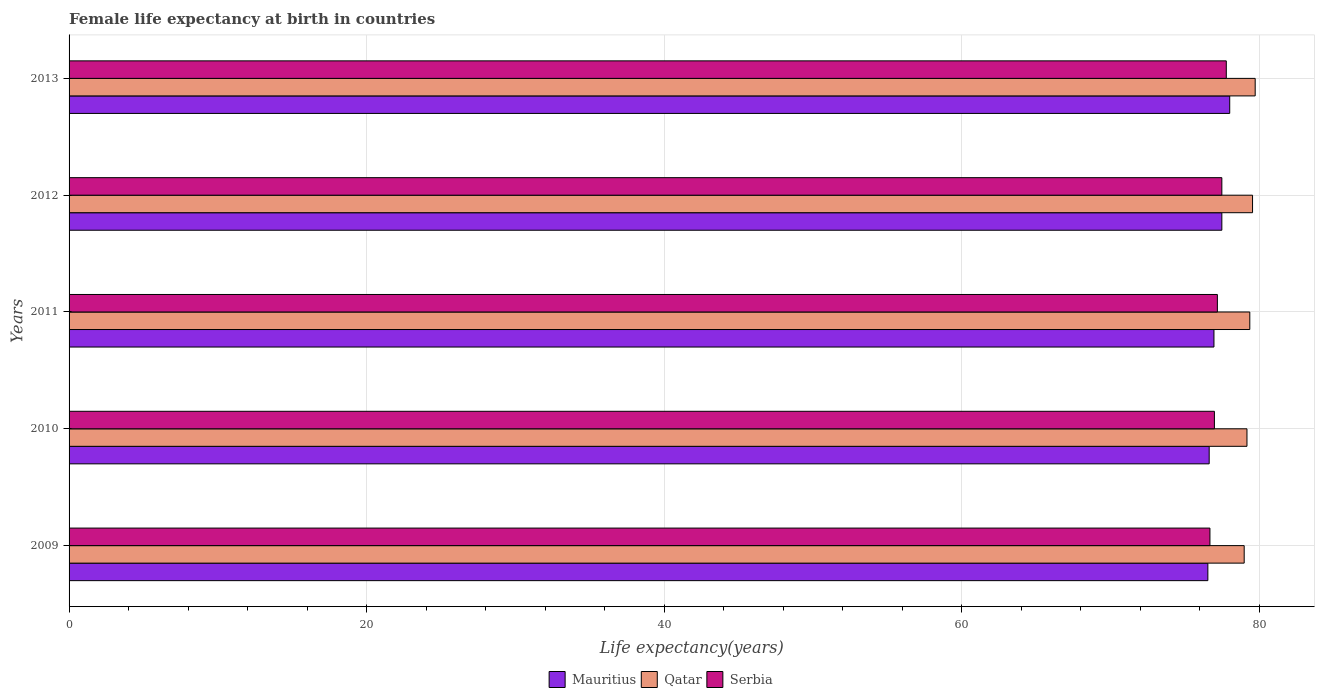How many different coloured bars are there?
Offer a terse response. 3. How many groups of bars are there?
Provide a short and direct response. 5. Are the number of bars on each tick of the Y-axis equal?
Provide a succinct answer. Yes. What is the label of the 5th group of bars from the top?
Offer a very short reply. 2009. In how many cases, is the number of bars for a given year not equal to the number of legend labels?
Make the answer very short. 0. What is the female life expectancy at birth in Mauritius in 2009?
Your answer should be very brief. 76.56. Across all years, what is the maximum female life expectancy at birth in Qatar?
Your answer should be very brief. 79.74. Across all years, what is the minimum female life expectancy at birth in Serbia?
Provide a succinct answer. 76.7. What is the total female life expectancy at birth in Qatar in the graph?
Offer a very short reply. 396.88. What is the difference between the female life expectancy at birth in Qatar in 2009 and that in 2010?
Provide a short and direct response. -0.19. What is the difference between the female life expectancy at birth in Qatar in 2011 and the female life expectancy at birth in Serbia in 2012?
Your answer should be very brief. 1.88. What is the average female life expectancy at birth in Mauritius per year?
Your response must be concise. 77.14. In the year 2013, what is the difference between the female life expectancy at birth in Mauritius and female life expectancy at birth in Qatar?
Make the answer very short. -1.71. In how many years, is the female life expectancy at birth in Serbia greater than 44 years?
Make the answer very short. 5. What is the ratio of the female life expectancy at birth in Serbia in 2009 to that in 2011?
Provide a short and direct response. 0.99. Is the female life expectancy at birth in Mauritius in 2012 less than that in 2013?
Provide a succinct answer. Yes. Is the difference between the female life expectancy at birth in Mauritius in 2009 and 2011 greater than the difference between the female life expectancy at birth in Qatar in 2009 and 2011?
Offer a terse response. No. What is the difference between the highest and the second highest female life expectancy at birth in Serbia?
Ensure brevity in your answer.  0.3. What is the difference between the highest and the lowest female life expectancy at birth in Mauritius?
Keep it short and to the point. 1.47. What does the 3rd bar from the top in 2012 represents?
Your response must be concise. Mauritius. What does the 2nd bar from the bottom in 2010 represents?
Your response must be concise. Qatar. How many bars are there?
Ensure brevity in your answer.  15. How many years are there in the graph?
Keep it short and to the point. 5. Are the values on the major ticks of X-axis written in scientific E-notation?
Your answer should be very brief. No. Does the graph contain any zero values?
Give a very brief answer. No. How many legend labels are there?
Offer a very short reply. 3. What is the title of the graph?
Offer a very short reply. Female life expectancy at birth in countries. Does "Venezuela" appear as one of the legend labels in the graph?
Your answer should be compact. No. What is the label or title of the X-axis?
Your answer should be very brief. Life expectancy(years). What is the Life expectancy(years) in Mauritius in 2009?
Keep it short and to the point. 76.56. What is the Life expectancy(years) of Qatar in 2009?
Ensure brevity in your answer.  79. What is the Life expectancy(years) of Serbia in 2009?
Ensure brevity in your answer.  76.7. What is the Life expectancy(years) in Mauritius in 2010?
Provide a succinct answer. 76.65. What is the Life expectancy(years) in Qatar in 2010?
Offer a very short reply. 79.19. What is the Life expectancy(years) in Mauritius in 2011?
Your answer should be very brief. 76.97. What is the Life expectancy(years) in Qatar in 2011?
Keep it short and to the point. 79.38. What is the Life expectancy(years) of Serbia in 2011?
Provide a succinct answer. 77.2. What is the Life expectancy(years) of Mauritius in 2012?
Your answer should be very brief. 77.5. What is the Life expectancy(years) of Qatar in 2012?
Offer a very short reply. 79.56. What is the Life expectancy(years) in Serbia in 2012?
Offer a terse response. 77.5. What is the Life expectancy(years) of Mauritius in 2013?
Provide a short and direct response. 78.03. What is the Life expectancy(years) in Qatar in 2013?
Your answer should be very brief. 79.74. What is the Life expectancy(years) of Serbia in 2013?
Provide a succinct answer. 77.8. Across all years, what is the maximum Life expectancy(years) of Mauritius?
Provide a short and direct response. 78.03. Across all years, what is the maximum Life expectancy(years) in Qatar?
Ensure brevity in your answer.  79.74. Across all years, what is the maximum Life expectancy(years) of Serbia?
Make the answer very short. 77.8. Across all years, what is the minimum Life expectancy(years) of Mauritius?
Your response must be concise. 76.56. Across all years, what is the minimum Life expectancy(years) in Qatar?
Ensure brevity in your answer.  79. Across all years, what is the minimum Life expectancy(years) in Serbia?
Provide a short and direct response. 76.7. What is the total Life expectancy(years) in Mauritius in the graph?
Your response must be concise. 385.71. What is the total Life expectancy(years) of Qatar in the graph?
Your answer should be very brief. 396.88. What is the total Life expectancy(years) in Serbia in the graph?
Provide a succinct answer. 386.2. What is the difference between the Life expectancy(years) of Mauritius in 2009 and that in 2010?
Provide a short and direct response. -0.09. What is the difference between the Life expectancy(years) in Qatar in 2009 and that in 2010?
Your response must be concise. -0.19. What is the difference between the Life expectancy(years) in Serbia in 2009 and that in 2010?
Provide a short and direct response. -0.3. What is the difference between the Life expectancy(years) in Mauritius in 2009 and that in 2011?
Ensure brevity in your answer.  -0.41. What is the difference between the Life expectancy(years) of Qatar in 2009 and that in 2011?
Your answer should be compact. -0.38. What is the difference between the Life expectancy(years) in Mauritius in 2009 and that in 2012?
Your answer should be very brief. -0.94. What is the difference between the Life expectancy(years) in Qatar in 2009 and that in 2012?
Offer a very short reply. -0.56. What is the difference between the Life expectancy(years) in Serbia in 2009 and that in 2012?
Offer a very short reply. -0.8. What is the difference between the Life expectancy(years) of Mauritius in 2009 and that in 2013?
Ensure brevity in your answer.  -1.47. What is the difference between the Life expectancy(years) of Qatar in 2009 and that in 2013?
Keep it short and to the point. -0.74. What is the difference between the Life expectancy(years) in Mauritius in 2010 and that in 2011?
Offer a very short reply. -0.32. What is the difference between the Life expectancy(years) in Qatar in 2010 and that in 2011?
Offer a terse response. -0.19. What is the difference between the Life expectancy(years) in Serbia in 2010 and that in 2011?
Provide a short and direct response. -0.2. What is the difference between the Life expectancy(years) of Mauritius in 2010 and that in 2012?
Your answer should be very brief. -0.85. What is the difference between the Life expectancy(years) in Qatar in 2010 and that in 2012?
Your answer should be very brief. -0.38. What is the difference between the Life expectancy(years) of Mauritius in 2010 and that in 2013?
Provide a succinct answer. -1.38. What is the difference between the Life expectancy(years) in Qatar in 2010 and that in 2013?
Offer a terse response. -0.55. What is the difference between the Life expectancy(years) of Serbia in 2010 and that in 2013?
Provide a short and direct response. -0.8. What is the difference between the Life expectancy(years) in Mauritius in 2011 and that in 2012?
Ensure brevity in your answer.  -0.53. What is the difference between the Life expectancy(years) of Qatar in 2011 and that in 2012?
Give a very brief answer. -0.18. What is the difference between the Life expectancy(years) in Serbia in 2011 and that in 2012?
Ensure brevity in your answer.  -0.3. What is the difference between the Life expectancy(years) in Mauritius in 2011 and that in 2013?
Provide a short and direct response. -1.06. What is the difference between the Life expectancy(years) in Qatar in 2011 and that in 2013?
Provide a short and direct response. -0.36. What is the difference between the Life expectancy(years) in Mauritius in 2012 and that in 2013?
Make the answer very short. -0.53. What is the difference between the Life expectancy(years) of Qatar in 2012 and that in 2013?
Make the answer very short. -0.18. What is the difference between the Life expectancy(years) in Serbia in 2012 and that in 2013?
Offer a terse response. -0.3. What is the difference between the Life expectancy(years) in Mauritius in 2009 and the Life expectancy(years) in Qatar in 2010?
Ensure brevity in your answer.  -2.63. What is the difference between the Life expectancy(years) of Mauritius in 2009 and the Life expectancy(years) of Serbia in 2010?
Your answer should be compact. -0.44. What is the difference between the Life expectancy(years) in Qatar in 2009 and the Life expectancy(years) in Serbia in 2010?
Provide a short and direct response. 2. What is the difference between the Life expectancy(years) of Mauritius in 2009 and the Life expectancy(years) of Qatar in 2011?
Ensure brevity in your answer.  -2.82. What is the difference between the Life expectancy(years) of Mauritius in 2009 and the Life expectancy(years) of Serbia in 2011?
Your answer should be compact. -0.64. What is the difference between the Life expectancy(years) in Qatar in 2009 and the Life expectancy(years) in Serbia in 2011?
Offer a terse response. 1.8. What is the difference between the Life expectancy(years) in Mauritius in 2009 and the Life expectancy(years) in Qatar in 2012?
Your answer should be compact. -3. What is the difference between the Life expectancy(years) in Mauritius in 2009 and the Life expectancy(years) in Serbia in 2012?
Your answer should be compact. -0.94. What is the difference between the Life expectancy(years) in Qatar in 2009 and the Life expectancy(years) in Serbia in 2012?
Provide a short and direct response. 1.5. What is the difference between the Life expectancy(years) of Mauritius in 2009 and the Life expectancy(years) of Qatar in 2013?
Provide a succinct answer. -3.18. What is the difference between the Life expectancy(years) of Mauritius in 2009 and the Life expectancy(years) of Serbia in 2013?
Offer a very short reply. -1.24. What is the difference between the Life expectancy(years) in Qatar in 2009 and the Life expectancy(years) in Serbia in 2013?
Your answer should be very brief. 1.2. What is the difference between the Life expectancy(years) in Mauritius in 2010 and the Life expectancy(years) in Qatar in 2011?
Your answer should be very brief. -2.73. What is the difference between the Life expectancy(years) in Mauritius in 2010 and the Life expectancy(years) in Serbia in 2011?
Provide a succinct answer. -0.55. What is the difference between the Life expectancy(years) of Qatar in 2010 and the Life expectancy(years) of Serbia in 2011?
Your answer should be very brief. 1.99. What is the difference between the Life expectancy(years) of Mauritius in 2010 and the Life expectancy(years) of Qatar in 2012?
Ensure brevity in your answer.  -2.92. What is the difference between the Life expectancy(years) in Mauritius in 2010 and the Life expectancy(years) in Serbia in 2012?
Offer a terse response. -0.85. What is the difference between the Life expectancy(years) of Qatar in 2010 and the Life expectancy(years) of Serbia in 2012?
Offer a terse response. 1.69. What is the difference between the Life expectancy(years) of Mauritius in 2010 and the Life expectancy(years) of Qatar in 2013?
Your answer should be very brief. -3.09. What is the difference between the Life expectancy(years) of Mauritius in 2010 and the Life expectancy(years) of Serbia in 2013?
Provide a short and direct response. -1.15. What is the difference between the Life expectancy(years) of Qatar in 2010 and the Life expectancy(years) of Serbia in 2013?
Keep it short and to the point. 1.39. What is the difference between the Life expectancy(years) in Mauritius in 2011 and the Life expectancy(years) in Qatar in 2012?
Offer a very short reply. -2.6. What is the difference between the Life expectancy(years) in Mauritius in 2011 and the Life expectancy(years) in Serbia in 2012?
Keep it short and to the point. -0.53. What is the difference between the Life expectancy(years) in Qatar in 2011 and the Life expectancy(years) in Serbia in 2012?
Give a very brief answer. 1.88. What is the difference between the Life expectancy(years) of Mauritius in 2011 and the Life expectancy(years) of Qatar in 2013?
Give a very brief answer. -2.77. What is the difference between the Life expectancy(years) in Mauritius in 2011 and the Life expectancy(years) in Serbia in 2013?
Your answer should be compact. -0.83. What is the difference between the Life expectancy(years) in Qatar in 2011 and the Life expectancy(years) in Serbia in 2013?
Your answer should be compact. 1.58. What is the difference between the Life expectancy(years) of Mauritius in 2012 and the Life expectancy(years) of Qatar in 2013?
Offer a very short reply. -2.24. What is the difference between the Life expectancy(years) in Mauritius in 2012 and the Life expectancy(years) in Serbia in 2013?
Your answer should be very brief. -0.3. What is the difference between the Life expectancy(years) in Qatar in 2012 and the Life expectancy(years) in Serbia in 2013?
Keep it short and to the point. 1.76. What is the average Life expectancy(years) of Mauritius per year?
Give a very brief answer. 77.14. What is the average Life expectancy(years) in Qatar per year?
Your answer should be very brief. 79.38. What is the average Life expectancy(years) of Serbia per year?
Provide a short and direct response. 77.24. In the year 2009, what is the difference between the Life expectancy(years) of Mauritius and Life expectancy(years) of Qatar?
Give a very brief answer. -2.44. In the year 2009, what is the difference between the Life expectancy(years) of Mauritius and Life expectancy(years) of Serbia?
Offer a very short reply. -0.14. In the year 2009, what is the difference between the Life expectancy(years) of Qatar and Life expectancy(years) of Serbia?
Your answer should be compact. 2.3. In the year 2010, what is the difference between the Life expectancy(years) in Mauritius and Life expectancy(years) in Qatar?
Ensure brevity in your answer.  -2.54. In the year 2010, what is the difference between the Life expectancy(years) in Mauritius and Life expectancy(years) in Serbia?
Offer a terse response. -0.35. In the year 2010, what is the difference between the Life expectancy(years) in Qatar and Life expectancy(years) in Serbia?
Provide a short and direct response. 2.19. In the year 2011, what is the difference between the Life expectancy(years) of Mauritius and Life expectancy(years) of Qatar?
Offer a very short reply. -2.41. In the year 2011, what is the difference between the Life expectancy(years) in Mauritius and Life expectancy(years) in Serbia?
Your response must be concise. -0.23. In the year 2011, what is the difference between the Life expectancy(years) of Qatar and Life expectancy(years) of Serbia?
Keep it short and to the point. 2.18. In the year 2012, what is the difference between the Life expectancy(years) in Mauritius and Life expectancy(years) in Qatar?
Provide a succinct answer. -2.06. In the year 2012, what is the difference between the Life expectancy(years) of Mauritius and Life expectancy(years) of Serbia?
Provide a short and direct response. 0. In the year 2012, what is the difference between the Life expectancy(years) in Qatar and Life expectancy(years) in Serbia?
Offer a very short reply. 2.06. In the year 2013, what is the difference between the Life expectancy(years) in Mauritius and Life expectancy(years) in Qatar?
Keep it short and to the point. -1.71. In the year 2013, what is the difference between the Life expectancy(years) of Mauritius and Life expectancy(years) of Serbia?
Provide a succinct answer. 0.23. In the year 2013, what is the difference between the Life expectancy(years) in Qatar and Life expectancy(years) in Serbia?
Provide a succinct answer. 1.94. What is the ratio of the Life expectancy(years) in Qatar in 2009 to that in 2010?
Give a very brief answer. 1. What is the ratio of the Life expectancy(years) in Mauritius in 2009 to that in 2011?
Offer a terse response. 0.99. What is the ratio of the Life expectancy(years) in Qatar in 2009 to that in 2011?
Provide a succinct answer. 1. What is the ratio of the Life expectancy(years) in Mauritius in 2009 to that in 2012?
Give a very brief answer. 0.99. What is the ratio of the Life expectancy(years) in Qatar in 2009 to that in 2012?
Provide a short and direct response. 0.99. What is the ratio of the Life expectancy(years) in Serbia in 2009 to that in 2012?
Provide a succinct answer. 0.99. What is the ratio of the Life expectancy(years) in Mauritius in 2009 to that in 2013?
Provide a succinct answer. 0.98. What is the ratio of the Life expectancy(years) in Serbia in 2009 to that in 2013?
Give a very brief answer. 0.99. What is the ratio of the Life expectancy(years) in Mauritius in 2010 to that in 2011?
Your answer should be compact. 1. What is the ratio of the Life expectancy(years) in Serbia in 2010 to that in 2012?
Provide a short and direct response. 0.99. What is the ratio of the Life expectancy(years) in Mauritius in 2010 to that in 2013?
Your answer should be compact. 0.98. What is the ratio of the Life expectancy(years) in Qatar in 2010 to that in 2013?
Make the answer very short. 0.99. What is the ratio of the Life expectancy(years) in Serbia in 2011 to that in 2012?
Your answer should be compact. 1. What is the ratio of the Life expectancy(years) of Mauritius in 2011 to that in 2013?
Your answer should be very brief. 0.99. What is the ratio of the Life expectancy(years) of Qatar in 2012 to that in 2013?
Provide a short and direct response. 1. What is the difference between the highest and the second highest Life expectancy(years) of Mauritius?
Provide a succinct answer. 0.53. What is the difference between the highest and the second highest Life expectancy(years) of Qatar?
Your response must be concise. 0.18. What is the difference between the highest and the lowest Life expectancy(years) in Mauritius?
Give a very brief answer. 1.47. What is the difference between the highest and the lowest Life expectancy(years) of Qatar?
Keep it short and to the point. 0.74. What is the difference between the highest and the lowest Life expectancy(years) of Serbia?
Ensure brevity in your answer.  1.1. 